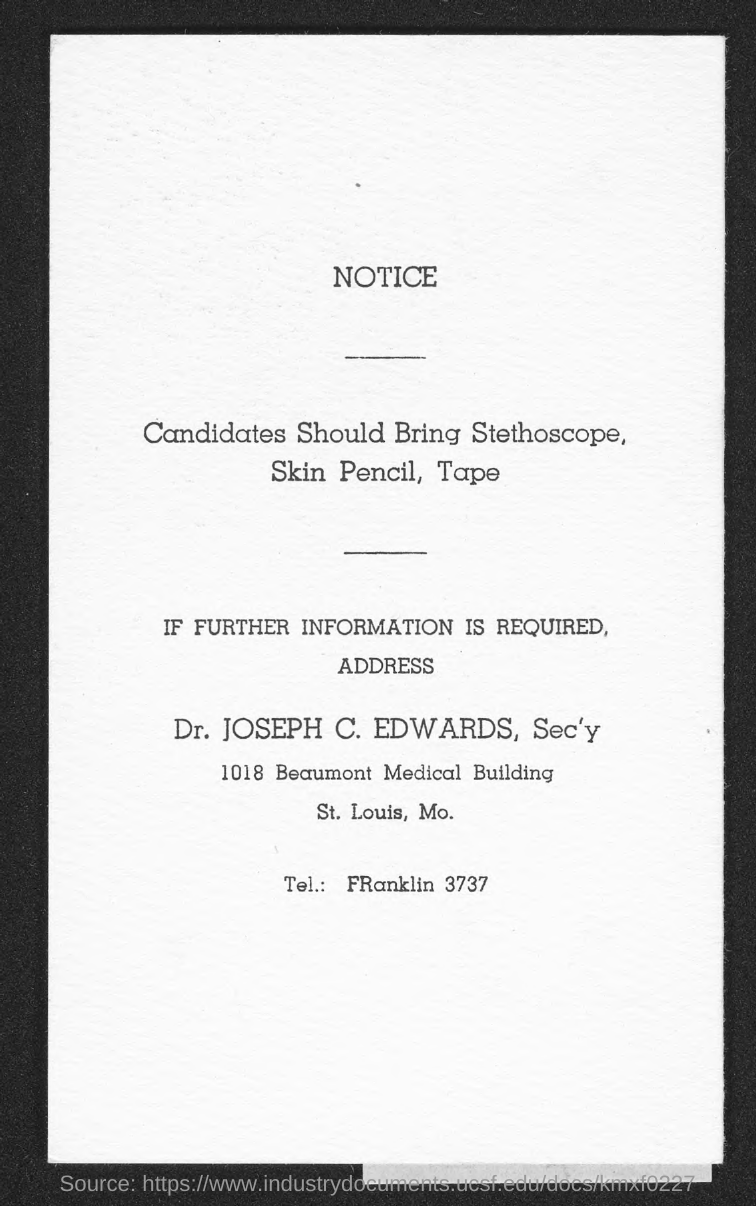Give some essential details in this illustration. Dr. Joseph C. Edwards is designated as Secretary. The notice states that if further information is required, the person to contact is Dr. Joseph C. Edwards, the Secretary. Please mention the Beaumont Medical Building number when calling. Provide the phone number of Franklin? It is 3737.. 